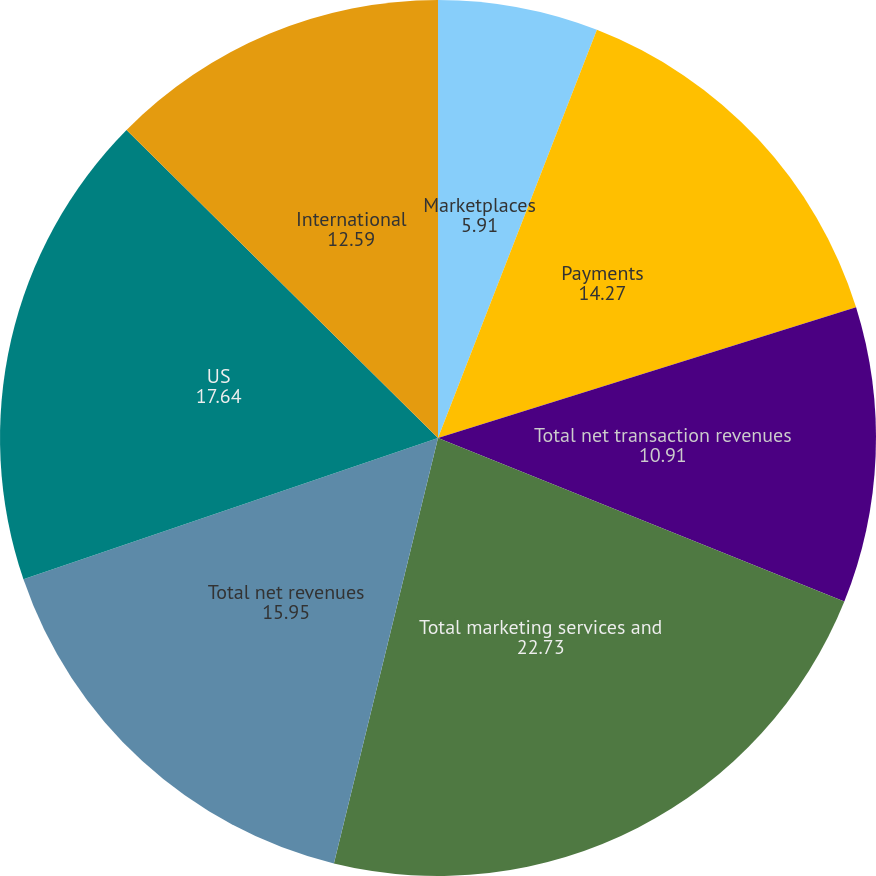Convert chart to OTSL. <chart><loc_0><loc_0><loc_500><loc_500><pie_chart><fcel>Marketplaces<fcel>Payments<fcel>Total net transaction revenues<fcel>Total marketing services and<fcel>Total net revenues<fcel>US<fcel>International<nl><fcel>5.91%<fcel>14.27%<fcel>10.91%<fcel>22.73%<fcel>15.95%<fcel>17.64%<fcel>12.59%<nl></chart> 